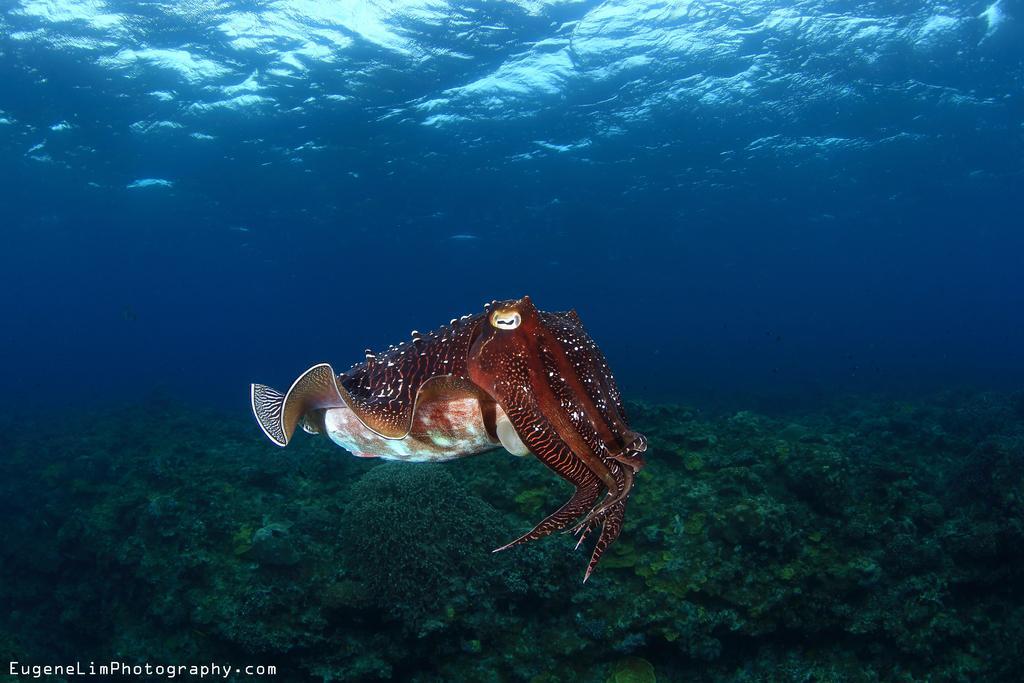Can you describe this image briefly? In this image I can see an octopus in brown color at the bottom there is plankton, at the top it is water. 